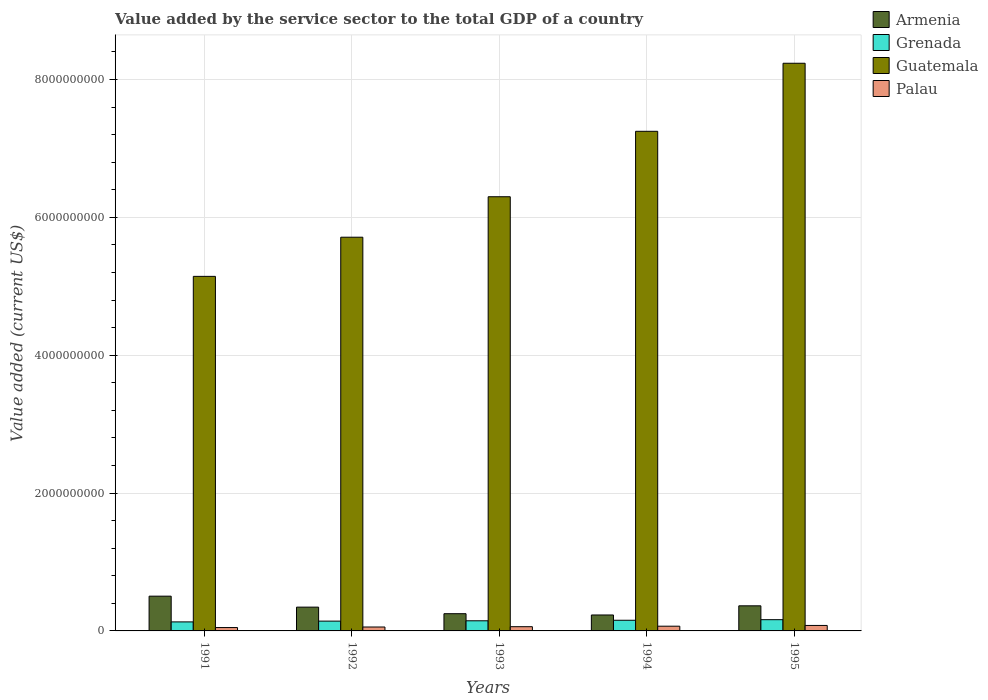How many groups of bars are there?
Provide a succinct answer. 5. Are the number of bars per tick equal to the number of legend labels?
Make the answer very short. Yes. In how many cases, is the number of bars for a given year not equal to the number of legend labels?
Offer a terse response. 0. What is the value added by the service sector to the total GDP in Armenia in 1993?
Your answer should be very brief. 2.50e+08. Across all years, what is the maximum value added by the service sector to the total GDP in Palau?
Offer a very short reply. 7.95e+07. Across all years, what is the minimum value added by the service sector to the total GDP in Grenada?
Keep it short and to the point. 1.31e+08. In which year was the value added by the service sector to the total GDP in Guatemala maximum?
Give a very brief answer. 1995. In which year was the value added by the service sector to the total GDP in Palau minimum?
Your response must be concise. 1991. What is the total value added by the service sector to the total GDP in Grenada in the graph?
Make the answer very short. 7.38e+08. What is the difference between the value added by the service sector to the total GDP in Palau in 1991 and that in 1994?
Provide a succinct answer. -1.97e+07. What is the difference between the value added by the service sector to the total GDP in Palau in 1993 and the value added by the service sector to the total GDP in Armenia in 1994?
Make the answer very short. -1.70e+08. What is the average value added by the service sector to the total GDP in Palau per year?
Make the answer very short. 6.30e+07. In the year 1995, what is the difference between the value added by the service sector to the total GDP in Guatemala and value added by the service sector to the total GDP in Palau?
Your response must be concise. 8.16e+09. What is the ratio of the value added by the service sector to the total GDP in Grenada in 1994 to that in 1995?
Your answer should be compact. 0.95. What is the difference between the highest and the second highest value added by the service sector to the total GDP in Palau?
Offer a terse response. 1.09e+07. What is the difference between the highest and the lowest value added by the service sector to the total GDP in Palau?
Offer a very short reply. 3.06e+07. In how many years, is the value added by the service sector to the total GDP in Guatemala greater than the average value added by the service sector to the total GDP in Guatemala taken over all years?
Offer a terse response. 2. What does the 3rd bar from the left in 1992 represents?
Offer a very short reply. Guatemala. What does the 1st bar from the right in 1991 represents?
Give a very brief answer. Palau. Are all the bars in the graph horizontal?
Offer a very short reply. No. How many years are there in the graph?
Offer a terse response. 5. What is the difference between two consecutive major ticks on the Y-axis?
Ensure brevity in your answer.  2.00e+09. Are the values on the major ticks of Y-axis written in scientific E-notation?
Your response must be concise. No. Where does the legend appear in the graph?
Make the answer very short. Top right. What is the title of the graph?
Your answer should be very brief. Value added by the service sector to the total GDP of a country. What is the label or title of the X-axis?
Provide a short and direct response. Years. What is the label or title of the Y-axis?
Your response must be concise. Value added (current US$). What is the Value added (current US$) of Armenia in 1991?
Ensure brevity in your answer.  5.04e+08. What is the Value added (current US$) in Grenada in 1991?
Your answer should be compact. 1.31e+08. What is the Value added (current US$) in Guatemala in 1991?
Your response must be concise. 5.14e+09. What is the Value added (current US$) in Palau in 1991?
Your answer should be compact. 4.89e+07. What is the Value added (current US$) of Armenia in 1992?
Make the answer very short. 3.45e+08. What is the Value added (current US$) of Grenada in 1992?
Your answer should be compact. 1.42e+08. What is the Value added (current US$) in Guatemala in 1992?
Your answer should be very brief. 5.71e+09. What is the Value added (current US$) of Palau in 1992?
Offer a very short reply. 5.68e+07. What is the Value added (current US$) in Armenia in 1993?
Offer a very short reply. 2.50e+08. What is the Value added (current US$) in Grenada in 1993?
Your answer should be very brief. 1.47e+08. What is the Value added (current US$) of Guatemala in 1993?
Offer a terse response. 6.30e+09. What is the Value added (current US$) of Palau in 1993?
Make the answer very short. 6.12e+07. What is the Value added (current US$) of Armenia in 1994?
Give a very brief answer. 2.31e+08. What is the Value added (current US$) of Grenada in 1994?
Ensure brevity in your answer.  1.55e+08. What is the Value added (current US$) in Guatemala in 1994?
Offer a very short reply. 7.25e+09. What is the Value added (current US$) in Palau in 1994?
Your answer should be compact. 6.86e+07. What is the Value added (current US$) of Armenia in 1995?
Provide a succinct answer. 3.64e+08. What is the Value added (current US$) of Grenada in 1995?
Provide a succinct answer. 1.63e+08. What is the Value added (current US$) in Guatemala in 1995?
Provide a succinct answer. 8.24e+09. What is the Value added (current US$) in Palau in 1995?
Give a very brief answer. 7.95e+07. Across all years, what is the maximum Value added (current US$) in Armenia?
Offer a very short reply. 5.04e+08. Across all years, what is the maximum Value added (current US$) in Grenada?
Your answer should be very brief. 1.63e+08. Across all years, what is the maximum Value added (current US$) in Guatemala?
Keep it short and to the point. 8.24e+09. Across all years, what is the maximum Value added (current US$) of Palau?
Keep it short and to the point. 7.95e+07. Across all years, what is the minimum Value added (current US$) in Armenia?
Provide a short and direct response. 2.31e+08. Across all years, what is the minimum Value added (current US$) in Grenada?
Make the answer very short. 1.31e+08. Across all years, what is the minimum Value added (current US$) in Guatemala?
Provide a short and direct response. 5.14e+09. Across all years, what is the minimum Value added (current US$) of Palau?
Provide a short and direct response. 4.89e+07. What is the total Value added (current US$) in Armenia in the graph?
Offer a very short reply. 1.69e+09. What is the total Value added (current US$) of Grenada in the graph?
Keep it short and to the point. 7.38e+08. What is the total Value added (current US$) in Guatemala in the graph?
Ensure brevity in your answer.  3.26e+1. What is the total Value added (current US$) of Palau in the graph?
Provide a succinct answer. 3.15e+08. What is the difference between the Value added (current US$) of Armenia in 1991 and that in 1992?
Your answer should be very brief. 1.59e+08. What is the difference between the Value added (current US$) in Grenada in 1991 and that in 1992?
Provide a short and direct response. -1.13e+07. What is the difference between the Value added (current US$) in Guatemala in 1991 and that in 1992?
Offer a terse response. -5.68e+08. What is the difference between the Value added (current US$) in Palau in 1991 and that in 1992?
Offer a very short reply. -7.90e+06. What is the difference between the Value added (current US$) of Armenia in 1991 and that in 1993?
Offer a very short reply. 2.55e+08. What is the difference between the Value added (current US$) in Grenada in 1991 and that in 1993?
Give a very brief answer. -1.61e+07. What is the difference between the Value added (current US$) of Guatemala in 1991 and that in 1993?
Offer a very short reply. -1.16e+09. What is the difference between the Value added (current US$) of Palau in 1991 and that in 1993?
Provide a short and direct response. -1.23e+07. What is the difference between the Value added (current US$) in Armenia in 1991 and that in 1994?
Ensure brevity in your answer.  2.73e+08. What is the difference between the Value added (current US$) of Grenada in 1991 and that in 1994?
Your answer should be compact. -2.39e+07. What is the difference between the Value added (current US$) in Guatemala in 1991 and that in 1994?
Your answer should be compact. -2.10e+09. What is the difference between the Value added (current US$) in Palau in 1991 and that in 1994?
Make the answer very short. -1.97e+07. What is the difference between the Value added (current US$) of Armenia in 1991 and that in 1995?
Make the answer very short. 1.40e+08. What is the difference between the Value added (current US$) in Grenada in 1991 and that in 1995?
Ensure brevity in your answer.  -3.22e+07. What is the difference between the Value added (current US$) in Guatemala in 1991 and that in 1995?
Ensure brevity in your answer.  -3.09e+09. What is the difference between the Value added (current US$) in Palau in 1991 and that in 1995?
Make the answer very short. -3.06e+07. What is the difference between the Value added (current US$) in Armenia in 1992 and that in 1993?
Provide a short and direct response. 9.53e+07. What is the difference between the Value added (current US$) of Grenada in 1992 and that in 1993?
Offer a very short reply. -4.74e+06. What is the difference between the Value added (current US$) of Guatemala in 1992 and that in 1993?
Your answer should be very brief. -5.87e+08. What is the difference between the Value added (current US$) of Palau in 1992 and that in 1993?
Provide a short and direct response. -4.41e+06. What is the difference between the Value added (current US$) in Armenia in 1992 and that in 1994?
Your answer should be compact. 1.14e+08. What is the difference between the Value added (current US$) in Grenada in 1992 and that in 1994?
Your answer should be compact. -1.26e+07. What is the difference between the Value added (current US$) of Guatemala in 1992 and that in 1994?
Keep it short and to the point. -1.54e+09. What is the difference between the Value added (current US$) of Palau in 1992 and that in 1994?
Offer a terse response. -1.18e+07. What is the difference between the Value added (current US$) in Armenia in 1992 and that in 1995?
Provide a succinct answer. -1.91e+07. What is the difference between the Value added (current US$) in Grenada in 1992 and that in 1995?
Give a very brief answer. -2.09e+07. What is the difference between the Value added (current US$) in Guatemala in 1992 and that in 1995?
Provide a succinct answer. -2.52e+09. What is the difference between the Value added (current US$) of Palau in 1992 and that in 1995?
Ensure brevity in your answer.  -2.27e+07. What is the difference between the Value added (current US$) in Armenia in 1993 and that in 1994?
Make the answer very short. 1.86e+07. What is the difference between the Value added (current US$) in Grenada in 1993 and that in 1994?
Your answer should be compact. -7.81e+06. What is the difference between the Value added (current US$) of Guatemala in 1993 and that in 1994?
Ensure brevity in your answer.  -9.49e+08. What is the difference between the Value added (current US$) in Palau in 1993 and that in 1994?
Ensure brevity in your answer.  -7.42e+06. What is the difference between the Value added (current US$) in Armenia in 1993 and that in 1995?
Make the answer very short. -1.14e+08. What is the difference between the Value added (current US$) in Grenada in 1993 and that in 1995?
Make the answer very short. -1.61e+07. What is the difference between the Value added (current US$) of Guatemala in 1993 and that in 1995?
Provide a short and direct response. -1.94e+09. What is the difference between the Value added (current US$) in Palau in 1993 and that in 1995?
Give a very brief answer. -1.83e+07. What is the difference between the Value added (current US$) in Armenia in 1994 and that in 1995?
Provide a succinct answer. -1.33e+08. What is the difference between the Value added (current US$) of Grenada in 1994 and that in 1995?
Offer a terse response. -8.31e+06. What is the difference between the Value added (current US$) in Guatemala in 1994 and that in 1995?
Provide a short and direct response. -9.87e+08. What is the difference between the Value added (current US$) of Palau in 1994 and that in 1995?
Provide a succinct answer. -1.09e+07. What is the difference between the Value added (current US$) of Armenia in 1991 and the Value added (current US$) of Grenada in 1992?
Your answer should be very brief. 3.62e+08. What is the difference between the Value added (current US$) in Armenia in 1991 and the Value added (current US$) in Guatemala in 1992?
Offer a very short reply. -5.21e+09. What is the difference between the Value added (current US$) of Armenia in 1991 and the Value added (current US$) of Palau in 1992?
Offer a terse response. 4.48e+08. What is the difference between the Value added (current US$) in Grenada in 1991 and the Value added (current US$) in Guatemala in 1992?
Give a very brief answer. -5.58e+09. What is the difference between the Value added (current US$) of Grenada in 1991 and the Value added (current US$) of Palau in 1992?
Provide a succinct answer. 7.41e+07. What is the difference between the Value added (current US$) of Guatemala in 1991 and the Value added (current US$) of Palau in 1992?
Your response must be concise. 5.09e+09. What is the difference between the Value added (current US$) in Armenia in 1991 and the Value added (current US$) in Grenada in 1993?
Give a very brief answer. 3.57e+08. What is the difference between the Value added (current US$) in Armenia in 1991 and the Value added (current US$) in Guatemala in 1993?
Give a very brief answer. -5.79e+09. What is the difference between the Value added (current US$) in Armenia in 1991 and the Value added (current US$) in Palau in 1993?
Your answer should be very brief. 4.43e+08. What is the difference between the Value added (current US$) in Grenada in 1991 and the Value added (current US$) in Guatemala in 1993?
Your answer should be very brief. -6.17e+09. What is the difference between the Value added (current US$) of Grenada in 1991 and the Value added (current US$) of Palau in 1993?
Keep it short and to the point. 6.96e+07. What is the difference between the Value added (current US$) in Guatemala in 1991 and the Value added (current US$) in Palau in 1993?
Offer a very short reply. 5.08e+09. What is the difference between the Value added (current US$) in Armenia in 1991 and the Value added (current US$) in Grenada in 1994?
Ensure brevity in your answer.  3.50e+08. What is the difference between the Value added (current US$) in Armenia in 1991 and the Value added (current US$) in Guatemala in 1994?
Ensure brevity in your answer.  -6.74e+09. What is the difference between the Value added (current US$) of Armenia in 1991 and the Value added (current US$) of Palau in 1994?
Your response must be concise. 4.36e+08. What is the difference between the Value added (current US$) in Grenada in 1991 and the Value added (current US$) in Guatemala in 1994?
Offer a very short reply. -7.12e+09. What is the difference between the Value added (current US$) in Grenada in 1991 and the Value added (current US$) in Palau in 1994?
Provide a short and direct response. 6.22e+07. What is the difference between the Value added (current US$) in Guatemala in 1991 and the Value added (current US$) in Palau in 1994?
Ensure brevity in your answer.  5.08e+09. What is the difference between the Value added (current US$) of Armenia in 1991 and the Value added (current US$) of Grenada in 1995?
Offer a terse response. 3.41e+08. What is the difference between the Value added (current US$) of Armenia in 1991 and the Value added (current US$) of Guatemala in 1995?
Your answer should be compact. -7.73e+09. What is the difference between the Value added (current US$) in Armenia in 1991 and the Value added (current US$) in Palau in 1995?
Offer a very short reply. 4.25e+08. What is the difference between the Value added (current US$) of Grenada in 1991 and the Value added (current US$) of Guatemala in 1995?
Offer a terse response. -8.10e+09. What is the difference between the Value added (current US$) of Grenada in 1991 and the Value added (current US$) of Palau in 1995?
Give a very brief answer. 5.13e+07. What is the difference between the Value added (current US$) of Guatemala in 1991 and the Value added (current US$) of Palau in 1995?
Your response must be concise. 5.06e+09. What is the difference between the Value added (current US$) of Armenia in 1992 and the Value added (current US$) of Grenada in 1993?
Your answer should be very brief. 1.98e+08. What is the difference between the Value added (current US$) in Armenia in 1992 and the Value added (current US$) in Guatemala in 1993?
Offer a terse response. -5.95e+09. What is the difference between the Value added (current US$) in Armenia in 1992 and the Value added (current US$) in Palau in 1993?
Provide a succinct answer. 2.84e+08. What is the difference between the Value added (current US$) of Grenada in 1992 and the Value added (current US$) of Guatemala in 1993?
Give a very brief answer. -6.16e+09. What is the difference between the Value added (current US$) in Grenada in 1992 and the Value added (current US$) in Palau in 1993?
Your answer should be compact. 8.10e+07. What is the difference between the Value added (current US$) of Guatemala in 1992 and the Value added (current US$) of Palau in 1993?
Give a very brief answer. 5.65e+09. What is the difference between the Value added (current US$) in Armenia in 1992 and the Value added (current US$) in Grenada in 1994?
Give a very brief answer. 1.90e+08. What is the difference between the Value added (current US$) in Armenia in 1992 and the Value added (current US$) in Guatemala in 1994?
Keep it short and to the point. -6.90e+09. What is the difference between the Value added (current US$) of Armenia in 1992 and the Value added (current US$) of Palau in 1994?
Give a very brief answer. 2.77e+08. What is the difference between the Value added (current US$) in Grenada in 1992 and the Value added (current US$) in Guatemala in 1994?
Provide a succinct answer. -7.11e+09. What is the difference between the Value added (current US$) of Grenada in 1992 and the Value added (current US$) of Palau in 1994?
Offer a terse response. 7.36e+07. What is the difference between the Value added (current US$) in Guatemala in 1992 and the Value added (current US$) in Palau in 1994?
Offer a very short reply. 5.64e+09. What is the difference between the Value added (current US$) of Armenia in 1992 and the Value added (current US$) of Grenada in 1995?
Keep it short and to the point. 1.82e+08. What is the difference between the Value added (current US$) of Armenia in 1992 and the Value added (current US$) of Guatemala in 1995?
Your answer should be very brief. -7.89e+09. What is the difference between the Value added (current US$) in Armenia in 1992 and the Value added (current US$) in Palau in 1995?
Offer a very short reply. 2.66e+08. What is the difference between the Value added (current US$) in Grenada in 1992 and the Value added (current US$) in Guatemala in 1995?
Provide a succinct answer. -8.09e+09. What is the difference between the Value added (current US$) in Grenada in 1992 and the Value added (current US$) in Palau in 1995?
Ensure brevity in your answer.  6.27e+07. What is the difference between the Value added (current US$) in Guatemala in 1992 and the Value added (current US$) in Palau in 1995?
Ensure brevity in your answer.  5.63e+09. What is the difference between the Value added (current US$) in Armenia in 1993 and the Value added (current US$) in Grenada in 1994?
Offer a terse response. 9.50e+07. What is the difference between the Value added (current US$) of Armenia in 1993 and the Value added (current US$) of Guatemala in 1994?
Offer a very short reply. -7.00e+09. What is the difference between the Value added (current US$) of Armenia in 1993 and the Value added (current US$) of Palau in 1994?
Your answer should be compact. 1.81e+08. What is the difference between the Value added (current US$) in Grenada in 1993 and the Value added (current US$) in Guatemala in 1994?
Your answer should be compact. -7.10e+09. What is the difference between the Value added (current US$) in Grenada in 1993 and the Value added (current US$) in Palau in 1994?
Give a very brief answer. 7.83e+07. What is the difference between the Value added (current US$) in Guatemala in 1993 and the Value added (current US$) in Palau in 1994?
Your answer should be very brief. 6.23e+09. What is the difference between the Value added (current US$) in Armenia in 1993 and the Value added (current US$) in Grenada in 1995?
Make the answer very short. 8.67e+07. What is the difference between the Value added (current US$) in Armenia in 1993 and the Value added (current US$) in Guatemala in 1995?
Your answer should be very brief. -7.99e+09. What is the difference between the Value added (current US$) in Armenia in 1993 and the Value added (current US$) in Palau in 1995?
Provide a short and direct response. 1.70e+08. What is the difference between the Value added (current US$) of Grenada in 1993 and the Value added (current US$) of Guatemala in 1995?
Your response must be concise. -8.09e+09. What is the difference between the Value added (current US$) of Grenada in 1993 and the Value added (current US$) of Palau in 1995?
Offer a very short reply. 6.74e+07. What is the difference between the Value added (current US$) in Guatemala in 1993 and the Value added (current US$) in Palau in 1995?
Give a very brief answer. 6.22e+09. What is the difference between the Value added (current US$) of Armenia in 1994 and the Value added (current US$) of Grenada in 1995?
Offer a very short reply. 6.81e+07. What is the difference between the Value added (current US$) of Armenia in 1994 and the Value added (current US$) of Guatemala in 1995?
Provide a succinct answer. -8.00e+09. What is the difference between the Value added (current US$) of Armenia in 1994 and the Value added (current US$) of Palau in 1995?
Your answer should be compact. 1.52e+08. What is the difference between the Value added (current US$) of Grenada in 1994 and the Value added (current US$) of Guatemala in 1995?
Your response must be concise. -8.08e+09. What is the difference between the Value added (current US$) in Grenada in 1994 and the Value added (current US$) in Palau in 1995?
Your answer should be very brief. 7.52e+07. What is the difference between the Value added (current US$) in Guatemala in 1994 and the Value added (current US$) in Palau in 1995?
Give a very brief answer. 7.17e+09. What is the average Value added (current US$) of Armenia per year?
Make the answer very short. 3.39e+08. What is the average Value added (current US$) in Grenada per year?
Give a very brief answer. 1.48e+08. What is the average Value added (current US$) in Guatemala per year?
Ensure brevity in your answer.  6.53e+09. What is the average Value added (current US$) in Palau per year?
Ensure brevity in your answer.  6.30e+07. In the year 1991, what is the difference between the Value added (current US$) in Armenia and Value added (current US$) in Grenada?
Your response must be concise. 3.73e+08. In the year 1991, what is the difference between the Value added (current US$) of Armenia and Value added (current US$) of Guatemala?
Ensure brevity in your answer.  -4.64e+09. In the year 1991, what is the difference between the Value added (current US$) of Armenia and Value added (current US$) of Palau?
Make the answer very short. 4.55e+08. In the year 1991, what is the difference between the Value added (current US$) of Grenada and Value added (current US$) of Guatemala?
Make the answer very short. -5.01e+09. In the year 1991, what is the difference between the Value added (current US$) in Grenada and Value added (current US$) in Palau?
Keep it short and to the point. 8.19e+07. In the year 1991, what is the difference between the Value added (current US$) in Guatemala and Value added (current US$) in Palau?
Ensure brevity in your answer.  5.09e+09. In the year 1992, what is the difference between the Value added (current US$) of Armenia and Value added (current US$) of Grenada?
Give a very brief answer. 2.03e+08. In the year 1992, what is the difference between the Value added (current US$) of Armenia and Value added (current US$) of Guatemala?
Your response must be concise. -5.37e+09. In the year 1992, what is the difference between the Value added (current US$) in Armenia and Value added (current US$) in Palau?
Ensure brevity in your answer.  2.88e+08. In the year 1992, what is the difference between the Value added (current US$) of Grenada and Value added (current US$) of Guatemala?
Offer a very short reply. -5.57e+09. In the year 1992, what is the difference between the Value added (current US$) in Grenada and Value added (current US$) in Palau?
Your answer should be compact. 8.54e+07. In the year 1992, what is the difference between the Value added (current US$) of Guatemala and Value added (current US$) of Palau?
Ensure brevity in your answer.  5.65e+09. In the year 1993, what is the difference between the Value added (current US$) of Armenia and Value added (current US$) of Grenada?
Your answer should be compact. 1.03e+08. In the year 1993, what is the difference between the Value added (current US$) of Armenia and Value added (current US$) of Guatemala?
Provide a succinct answer. -6.05e+09. In the year 1993, what is the difference between the Value added (current US$) in Armenia and Value added (current US$) in Palau?
Make the answer very short. 1.89e+08. In the year 1993, what is the difference between the Value added (current US$) of Grenada and Value added (current US$) of Guatemala?
Your response must be concise. -6.15e+09. In the year 1993, what is the difference between the Value added (current US$) in Grenada and Value added (current US$) in Palau?
Your answer should be compact. 8.57e+07. In the year 1993, what is the difference between the Value added (current US$) in Guatemala and Value added (current US$) in Palau?
Provide a short and direct response. 6.24e+09. In the year 1994, what is the difference between the Value added (current US$) in Armenia and Value added (current US$) in Grenada?
Ensure brevity in your answer.  7.65e+07. In the year 1994, what is the difference between the Value added (current US$) in Armenia and Value added (current US$) in Guatemala?
Provide a short and direct response. -7.02e+09. In the year 1994, what is the difference between the Value added (current US$) of Armenia and Value added (current US$) of Palau?
Your response must be concise. 1.63e+08. In the year 1994, what is the difference between the Value added (current US$) in Grenada and Value added (current US$) in Guatemala?
Give a very brief answer. -7.09e+09. In the year 1994, what is the difference between the Value added (current US$) of Grenada and Value added (current US$) of Palau?
Your answer should be compact. 8.61e+07. In the year 1994, what is the difference between the Value added (current US$) of Guatemala and Value added (current US$) of Palau?
Your answer should be compact. 7.18e+09. In the year 1995, what is the difference between the Value added (current US$) of Armenia and Value added (current US$) of Grenada?
Give a very brief answer. 2.01e+08. In the year 1995, what is the difference between the Value added (current US$) of Armenia and Value added (current US$) of Guatemala?
Your answer should be very brief. -7.87e+09. In the year 1995, what is the difference between the Value added (current US$) in Armenia and Value added (current US$) in Palau?
Your response must be concise. 2.85e+08. In the year 1995, what is the difference between the Value added (current US$) of Grenada and Value added (current US$) of Guatemala?
Your response must be concise. -8.07e+09. In the year 1995, what is the difference between the Value added (current US$) in Grenada and Value added (current US$) in Palau?
Your answer should be very brief. 8.35e+07. In the year 1995, what is the difference between the Value added (current US$) in Guatemala and Value added (current US$) in Palau?
Offer a very short reply. 8.16e+09. What is the ratio of the Value added (current US$) in Armenia in 1991 to that in 1992?
Your answer should be very brief. 1.46. What is the ratio of the Value added (current US$) of Grenada in 1991 to that in 1992?
Offer a very short reply. 0.92. What is the ratio of the Value added (current US$) of Guatemala in 1991 to that in 1992?
Your answer should be very brief. 0.9. What is the ratio of the Value added (current US$) of Palau in 1991 to that in 1992?
Offer a very short reply. 0.86. What is the ratio of the Value added (current US$) in Armenia in 1991 to that in 1993?
Provide a short and direct response. 2.02. What is the ratio of the Value added (current US$) in Grenada in 1991 to that in 1993?
Provide a short and direct response. 0.89. What is the ratio of the Value added (current US$) of Guatemala in 1991 to that in 1993?
Make the answer very short. 0.82. What is the ratio of the Value added (current US$) in Palau in 1991 to that in 1993?
Give a very brief answer. 0.8. What is the ratio of the Value added (current US$) of Armenia in 1991 to that in 1994?
Make the answer very short. 2.18. What is the ratio of the Value added (current US$) in Grenada in 1991 to that in 1994?
Your answer should be very brief. 0.85. What is the ratio of the Value added (current US$) of Guatemala in 1991 to that in 1994?
Your answer should be very brief. 0.71. What is the ratio of the Value added (current US$) of Palau in 1991 to that in 1994?
Provide a succinct answer. 0.71. What is the ratio of the Value added (current US$) of Armenia in 1991 to that in 1995?
Keep it short and to the point. 1.38. What is the ratio of the Value added (current US$) of Grenada in 1991 to that in 1995?
Keep it short and to the point. 0.8. What is the ratio of the Value added (current US$) in Guatemala in 1991 to that in 1995?
Make the answer very short. 0.62. What is the ratio of the Value added (current US$) in Palau in 1991 to that in 1995?
Your response must be concise. 0.61. What is the ratio of the Value added (current US$) of Armenia in 1992 to that in 1993?
Offer a terse response. 1.38. What is the ratio of the Value added (current US$) in Guatemala in 1992 to that in 1993?
Your response must be concise. 0.91. What is the ratio of the Value added (current US$) of Palau in 1992 to that in 1993?
Your answer should be compact. 0.93. What is the ratio of the Value added (current US$) of Armenia in 1992 to that in 1994?
Give a very brief answer. 1.49. What is the ratio of the Value added (current US$) in Grenada in 1992 to that in 1994?
Make the answer very short. 0.92. What is the ratio of the Value added (current US$) in Guatemala in 1992 to that in 1994?
Provide a succinct answer. 0.79. What is the ratio of the Value added (current US$) of Palau in 1992 to that in 1994?
Ensure brevity in your answer.  0.83. What is the ratio of the Value added (current US$) in Armenia in 1992 to that in 1995?
Your answer should be very brief. 0.95. What is the ratio of the Value added (current US$) of Grenada in 1992 to that in 1995?
Give a very brief answer. 0.87. What is the ratio of the Value added (current US$) in Guatemala in 1992 to that in 1995?
Your answer should be very brief. 0.69. What is the ratio of the Value added (current US$) of Palau in 1992 to that in 1995?
Keep it short and to the point. 0.71. What is the ratio of the Value added (current US$) in Armenia in 1993 to that in 1994?
Give a very brief answer. 1.08. What is the ratio of the Value added (current US$) of Grenada in 1993 to that in 1994?
Make the answer very short. 0.95. What is the ratio of the Value added (current US$) in Guatemala in 1993 to that in 1994?
Your answer should be very brief. 0.87. What is the ratio of the Value added (current US$) of Palau in 1993 to that in 1994?
Offer a very short reply. 0.89. What is the ratio of the Value added (current US$) of Armenia in 1993 to that in 1995?
Give a very brief answer. 0.69. What is the ratio of the Value added (current US$) in Grenada in 1993 to that in 1995?
Offer a terse response. 0.9. What is the ratio of the Value added (current US$) in Guatemala in 1993 to that in 1995?
Keep it short and to the point. 0.76. What is the ratio of the Value added (current US$) of Palau in 1993 to that in 1995?
Provide a short and direct response. 0.77. What is the ratio of the Value added (current US$) in Armenia in 1994 to that in 1995?
Offer a terse response. 0.63. What is the ratio of the Value added (current US$) in Grenada in 1994 to that in 1995?
Give a very brief answer. 0.95. What is the ratio of the Value added (current US$) in Guatemala in 1994 to that in 1995?
Your answer should be compact. 0.88. What is the ratio of the Value added (current US$) in Palau in 1994 to that in 1995?
Give a very brief answer. 0.86. What is the difference between the highest and the second highest Value added (current US$) in Armenia?
Keep it short and to the point. 1.40e+08. What is the difference between the highest and the second highest Value added (current US$) of Grenada?
Ensure brevity in your answer.  8.31e+06. What is the difference between the highest and the second highest Value added (current US$) in Guatemala?
Make the answer very short. 9.87e+08. What is the difference between the highest and the second highest Value added (current US$) in Palau?
Give a very brief answer. 1.09e+07. What is the difference between the highest and the lowest Value added (current US$) in Armenia?
Offer a terse response. 2.73e+08. What is the difference between the highest and the lowest Value added (current US$) of Grenada?
Your answer should be very brief. 3.22e+07. What is the difference between the highest and the lowest Value added (current US$) in Guatemala?
Make the answer very short. 3.09e+09. What is the difference between the highest and the lowest Value added (current US$) of Palau?
Your answer should be very brief. 3.06e+07. 